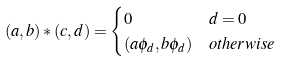<formula> <loc_0><loc_0><loc_500><loc_500>( a , b ) * ( c , d ) & = \begin{cases} 0 & d = 0 \\ ( a \phi _ { d } , b \phi _ { d } ) & o t h e r w i s e \end{cases}</formula> 